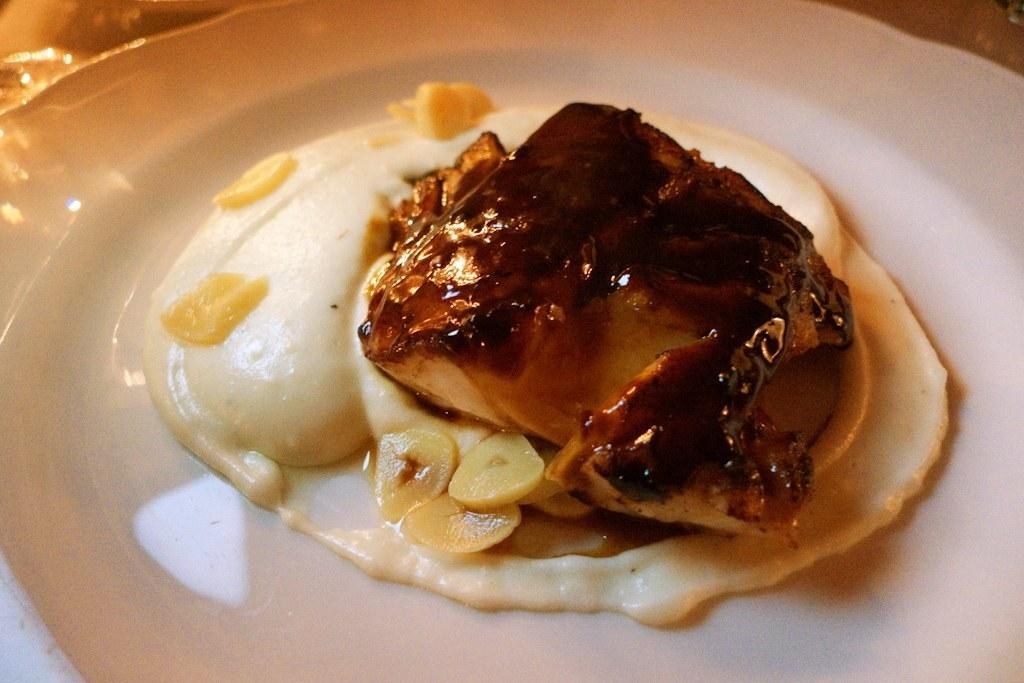What is on the plate that is visible in the image? The plate contains food. Where is the plate located in the image? The plate is placed on a surface. What type of tree is growing on the plate in the image? There is no tree growing on the plate in the image; it contains food. How many pages of the book are visible on the plate in the image? There is no book or page present on the plate in the image; it contains food. 